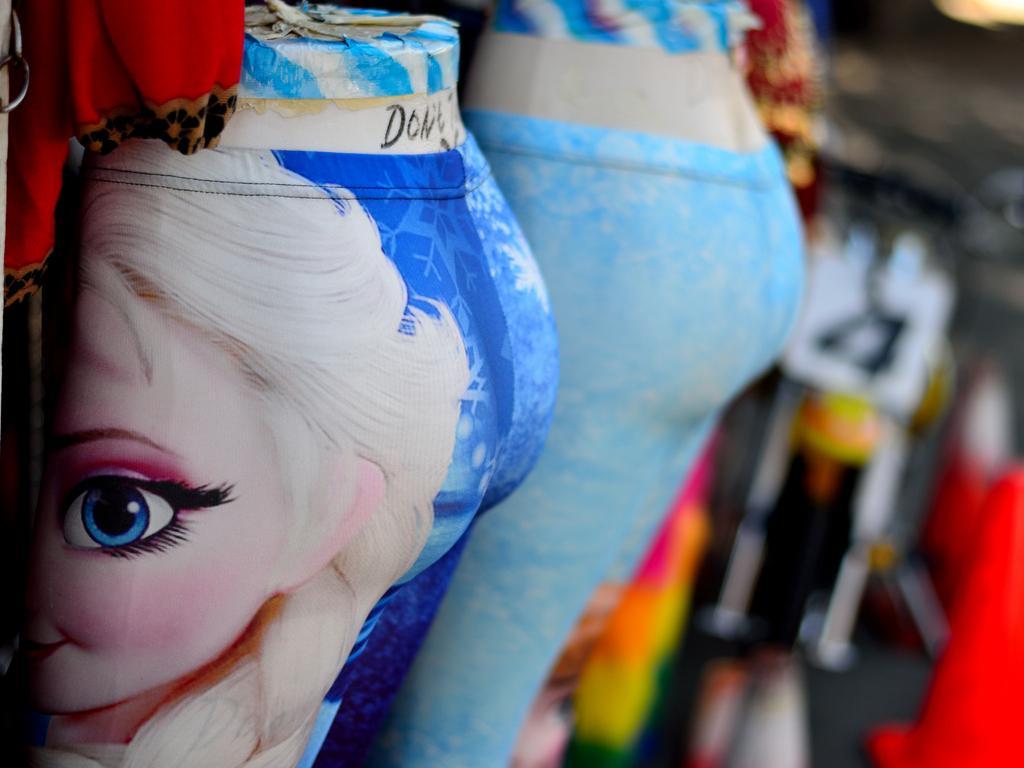How would you summarize this image in a sentence or two? Here in this picture we can see pants present on the doll over there and in the front we can see animation picture present on the pant over there. 